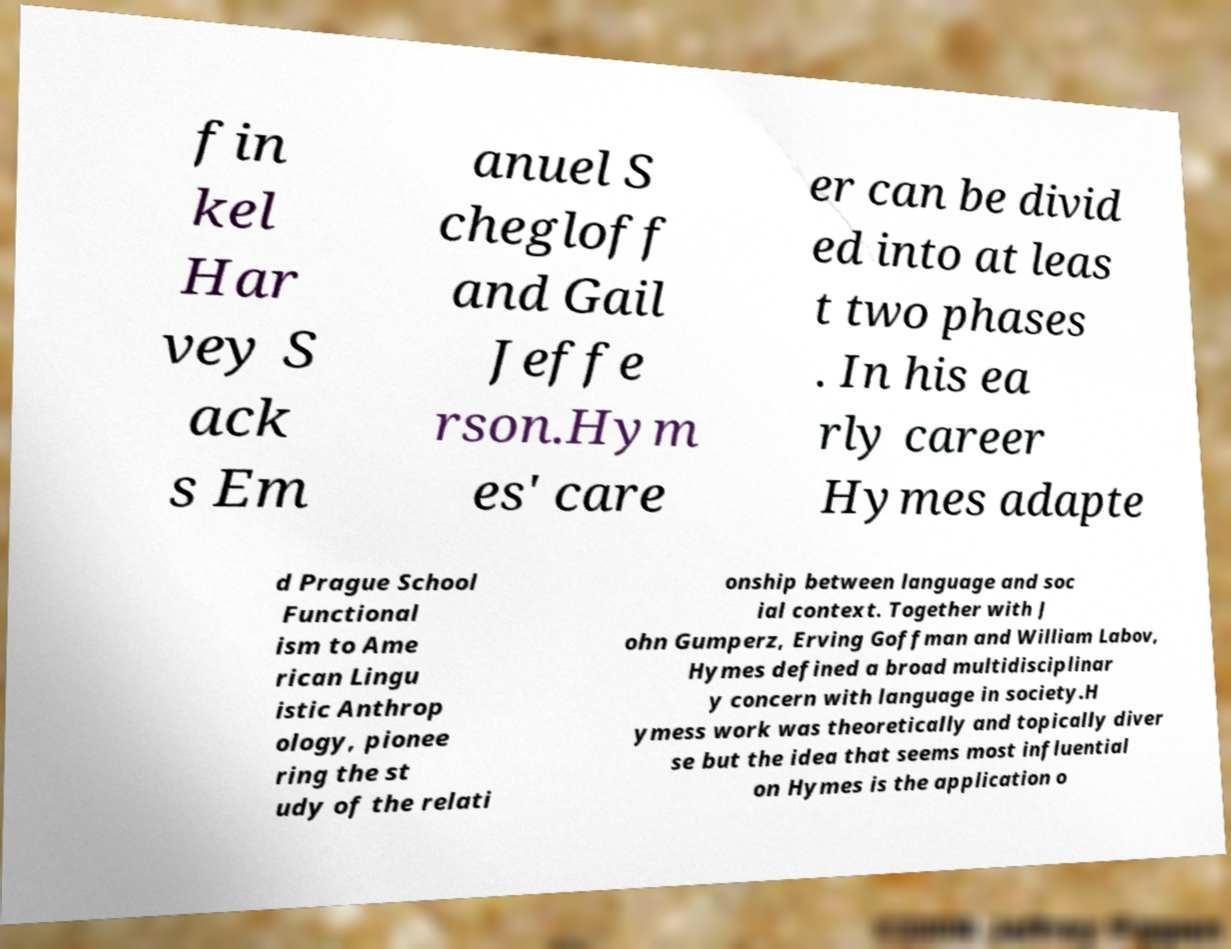Could you extract and type out the text from this image? fin kel Har vey S ack s Em anuel S chegloff and Gail Jeffe rson.Hym es' care er can be divid ed into at leas t two phases . In his ea rly career Hymes adapte d Prague School Functional ism to Ame rican Lingu istic Anthrop ology, pionee ring the st udy of the relati onship between language and soc ial context. Together with J ohn Gumperz, Erving Goffman and William Labov, Hymes defined a broad multidisciplinar y concern with language in society.H ymess work was theoretically and topically diver se but the idea that seems most influential on Hymes is the application o 